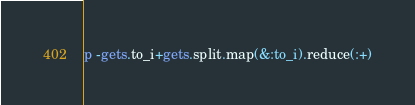Convert code to text. <code><loc_0><loc_0><loc_500><loc_500><_Ruby_>p -gets.to_i+gets.split.map(&:to_i).reduce(:+)</code> 